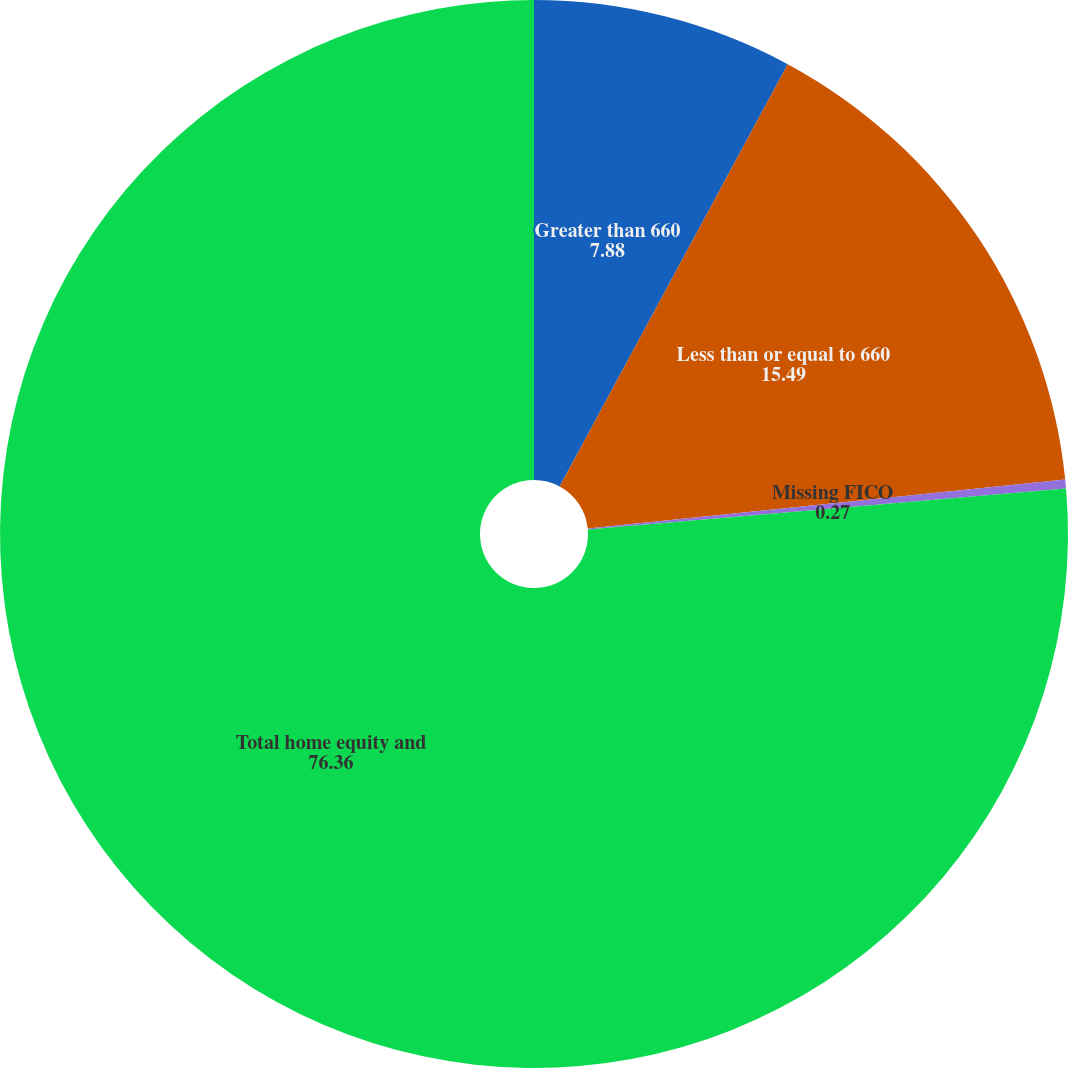<chart> <loc_0><loc_0><loc_500><loc_500><pie_chart><fcel>Greater than 660<fcel>Less than or equal to 660<fcel>Missing FICO<fcel>Total home equity and<nl><fcel>7.88%<fcel>15.49%<fcel>0.27%<fcel>76.36%<nl></chart> 